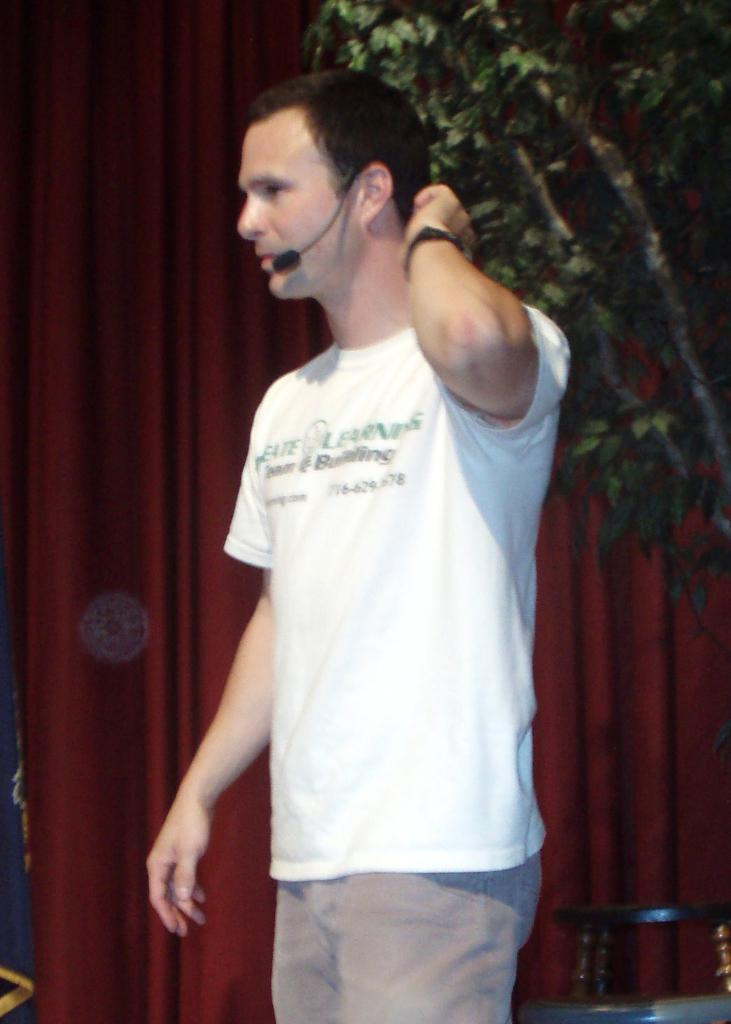What is the man in the image holding? The man is holding a microphone. What object is beside the man? There is a chair beside the man. What type of fabric can be seen in the image? There are curtains in the image. What type of natural element is visible in the image? There is a tree visible in the image. What type of marble is visible on the floor in the image? There is no marble visible on the floor in the image. What type of bread is the man eating in the image? There is no bread present in the image. 